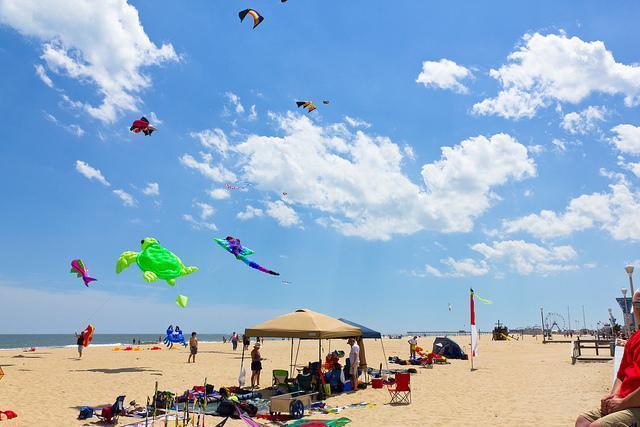How many birds on the beach are the right side of the surfers?
Give a very brief answer. 0. 